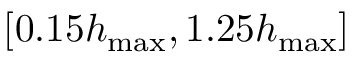<formula> <loc_0><loc_0><loc_500><loc_500>[ 0 . 1 5 h _ { \max } , 1 . 2 5 h _ { \max } ]</formula> 